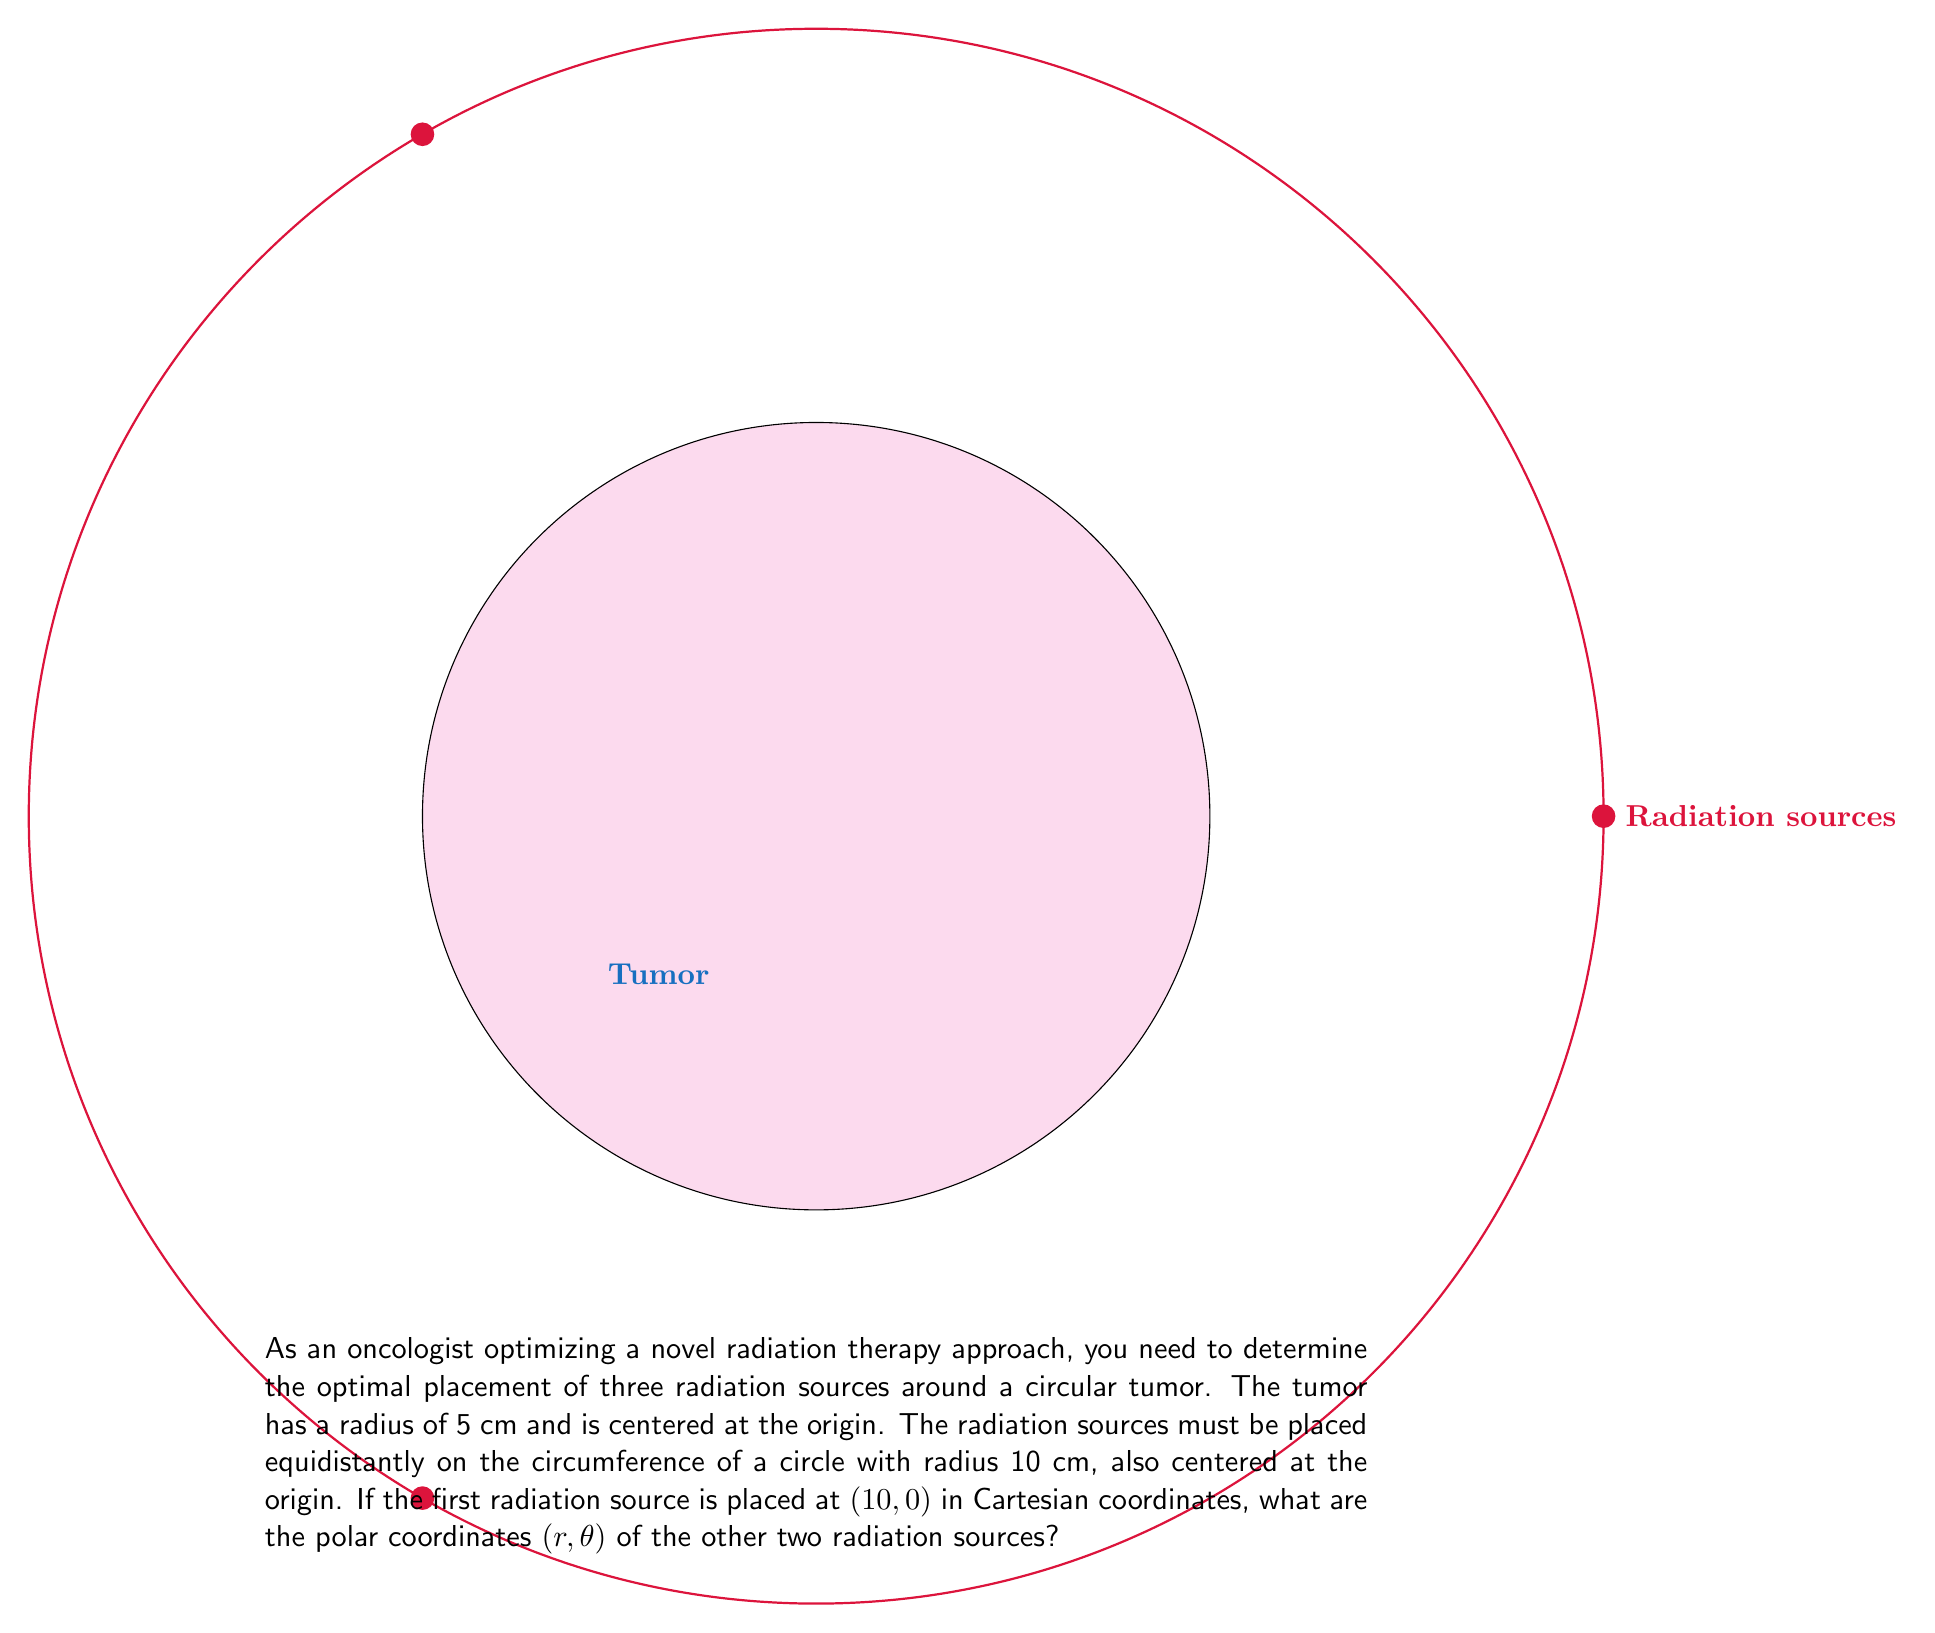Can you solve this math problem? Let's approach this step-by-step:

1) We know that the three radiation sources need to be placed equidistantly on the circumference of a circle. This means they will form an equilateral triangle, with each angle at the center being $\frac{2\pi}{3}$ radians or 120°.

2) The first source is given at $(10, 0)$ in Cartesian coordinates. In polar coordinates, this is $(10, 0)$.

3) For the second source, we rotate by $\frac{2\pi}{3}$ radians:
   $r = 10$ (unchanged)
   $\theta = \frac{2\pi}{3}$ radians

4) For the third source, we rotate by another $\frac{2\pi}{3}$ radians:
   $r = 10$ (unchanged)
   $\theta = \frac{4\pi}{3}$ radians

5) Therefore, the polar coordinates of the three sources are:
   Source 1: $(10, 0)$
   Source 2: $(10, \frac{2\pi}{3})$
   Source 3: $(10, \frac{4\pi}{3})$

This configuration ensures that the radiation sources are optimally placed to provide uniform coverage of the tumor.
Answer: $(10, \frac{2\pi}{3})$ and $(10, \frac{4\pi}{3})$ 